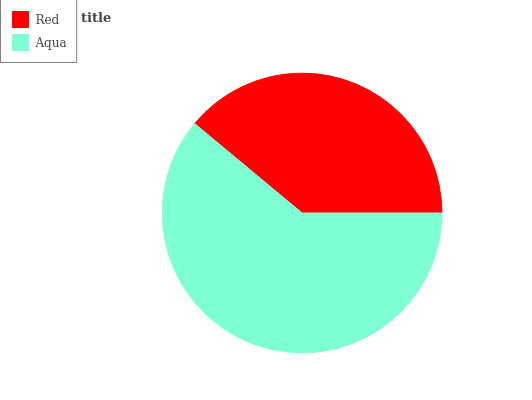Is Red the minimum?
Answer yes or no. Yes. Is Aqua the maximum?
Answer yes or no. Yes. Is Aqua the minimum?
Answer yes or no. No. Is Aqua greater than Red?
Answer yes or no. Yes. Is Red less than Aqua?
Answer yes or no. Yes. Is Red greater than Aqua?
Answer yes or no. No. Is Aqua less than Red?
Answer yes or no. No. Is Aqua the high median?
Answer yes or no. Yes. Is Red the low median?
Answer yes or no. Yes. Is Red the high median?
Answer yes or no. No. Is Aqua the low median?
Answer yes or no. No. 